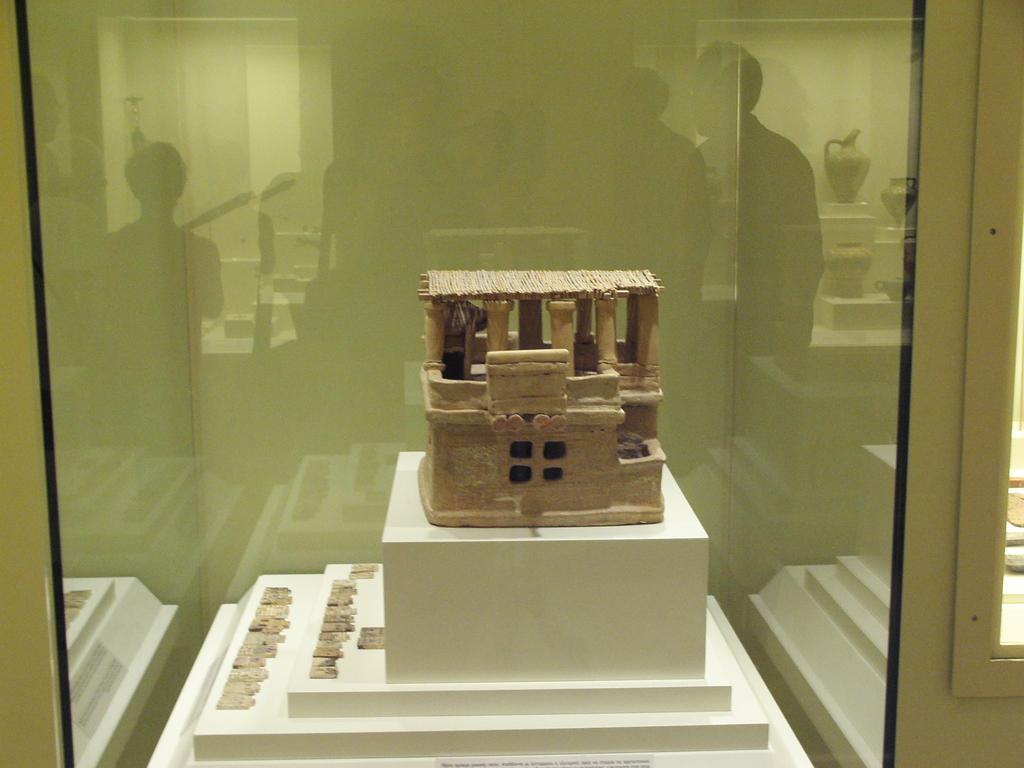Describe this image in one or two sentences. In this picture we can see a scale model house and some items on the object. In front of the scale model, there is a glass and on the glass we can see the reflection of people and some objects. 